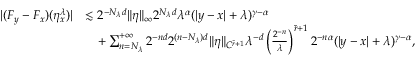Convert formula to latex. <formula><loc_0><loc_0><loc_500><loc_500>\begin{array} { r l } { | ( F _ { y } - F _ { x } ) ( \eta _ { x } ^ { \lambda } ) | } & { \lesssim 2 ^ { - N _ { \lambda } d } \| \eta \| _ { \infty } 2 ^ { N _ { \lambda } d } \lambda ^ { \alpha } ( | y - x | + \lambda ) ^ { \gamma - \alpha } } \\ & { \quad + \sum _ { n = N _ { \lambda } } ^ { + \infty } 2 ^ { - n d } 2 ^ { ( n - N _ { \lambda } ) d } \| \eta \| _ { C ^ { \tilde { r } + 1 } } \lambda ^ { - d } \left ( \frac { 2 ^ { - n } } { \lambda } \right ) ^ { \tilde { r } + 1 } 2 ^ { - n \alpha } ( | y - x | + \lambda ) ^ { \gamma - \alpha } , } \end{array}</formula> 